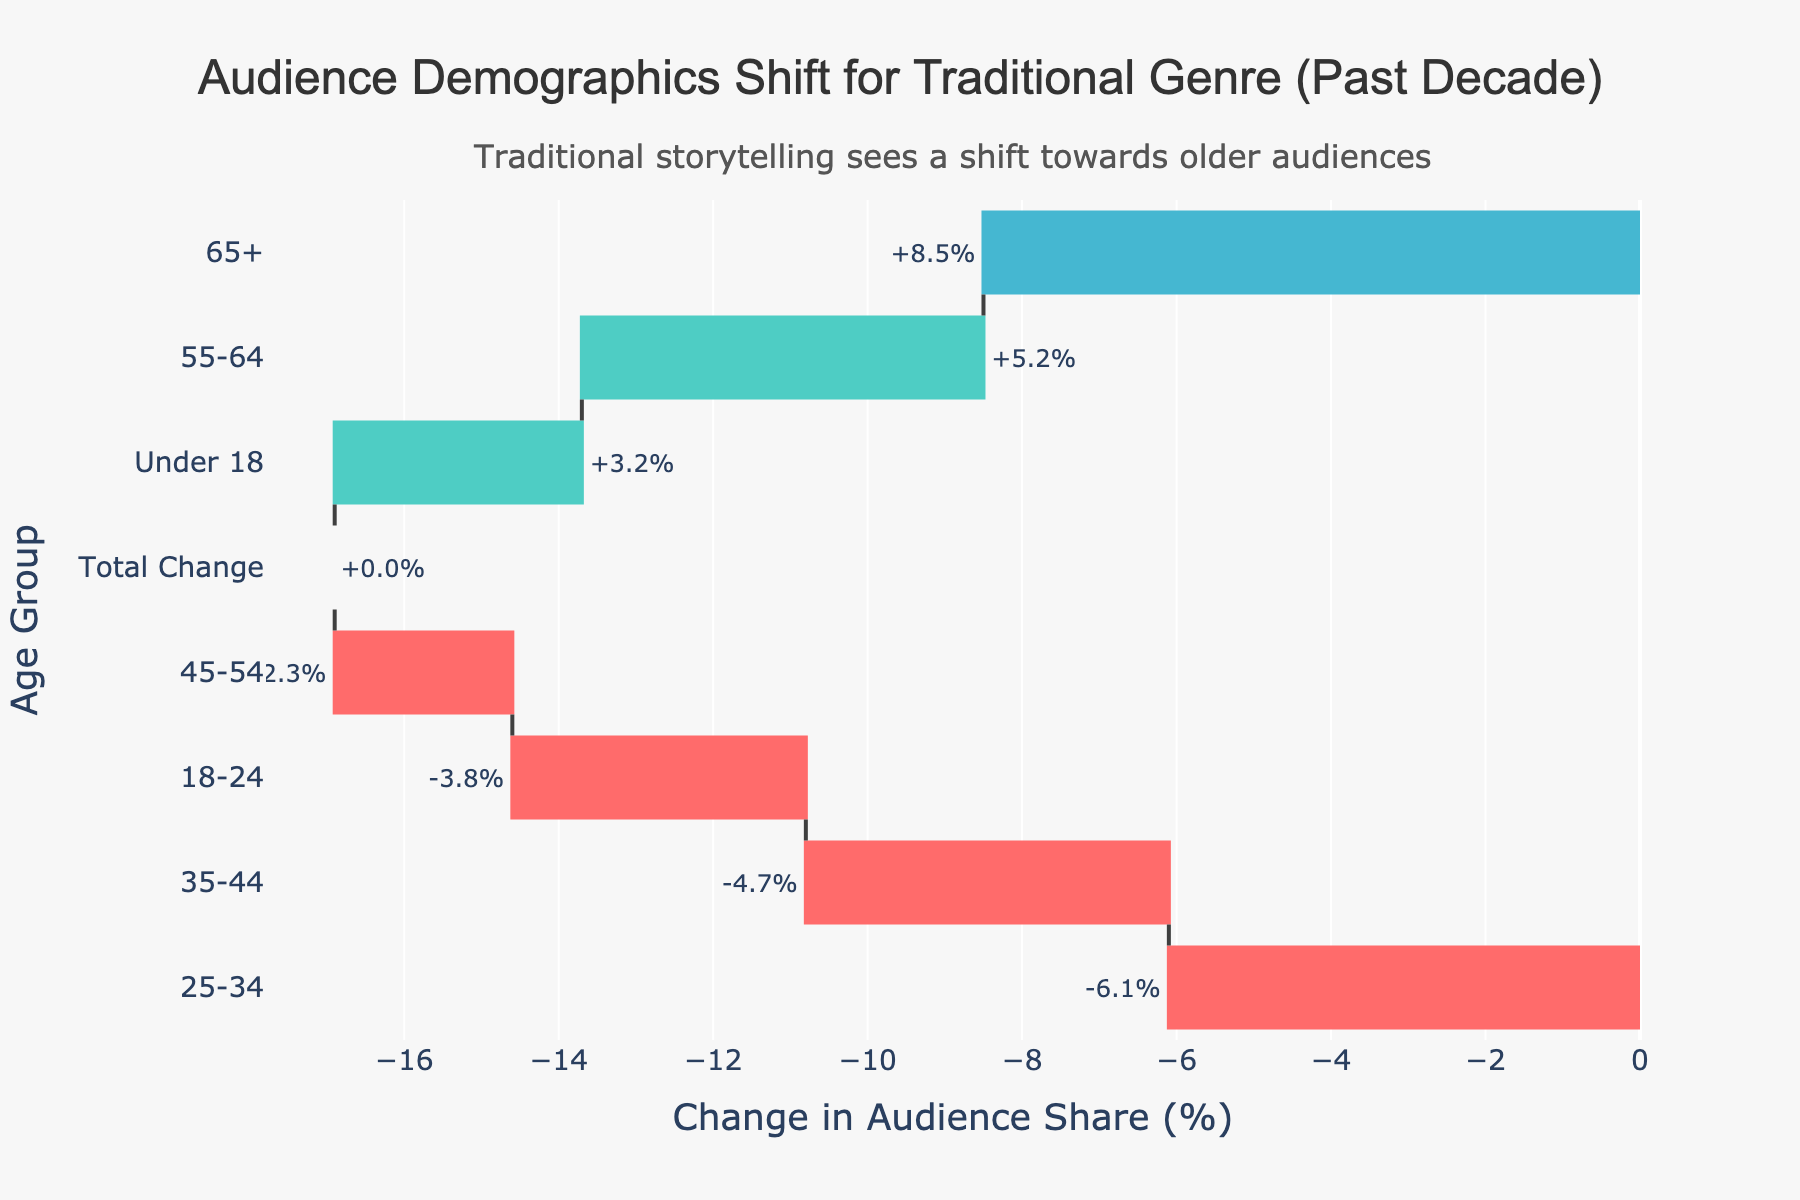what is the title of the figure? The title is usually placed at the top of the figure, centrally aligned. It reads "Audience Demographics Shift for Traditional Genre (Past Decade)"
Answer: Audience Demographics Shift for Traditional Genre (Past Decade) What is the visual appearance of the audience share change for the age group 65+? By checking the bar for the age group 65+, it should be green, indicating a positive change. The value at the end of the bar shows "+8.5%".
Answer: Green, +8.5% What change percentage in audience share does the age group 25-34 have? Locate the bar corresponding to the age group 25-34. The percentage displayed outside the bar is "-6.1%".
Answer: -6.1% Which age group had the largest positive change in audience share? Compare the positive values outside the bars. The group with the largest positive value is the age group 65+ with "+8.5%".
Answer: 65+ Which age group had the most significant decrease in audience share? Compare the negative values outside the bars. The group with the largest negative value is the age group 25-34 with "-6.1%".
Answer: 25-34 What is the total change in audience share, as shown in the chart? The chart has a bar labeled "Total Change", which is shown as "0" both in the bar and on the y-axis.
Answer: 0 How much did the audience share for the age group under 18 change by? Identify the bar for the age group under 18 and read the percentage change shown outside the bar, which is "+3.2%".
Answer: +3.2% Are there more age groups with an increased or decreased audience share? Count the number of green bars for increased share and red bars for decreased share. There are 3 green bars (increased) and 4 red bars (decreased).
Answer: Decreased What is the combined percentage change in audience share for age groups 55-64 and under 18? Add the changes shown for age groups 55-64 (+5.2%) and under 18 (+3.2%) together: 5.2% + 3.2% = 8.4%.
Answer: +8.4% How does the change in audience share for the group 18-24 compare to the group 45-54? The change for the group 18-24 is -3.8%, while for the group 45-54, it is -2.3%. The group 18-24 has a larger decrease compared to the group 45-54.
Answer: Larger decrease 